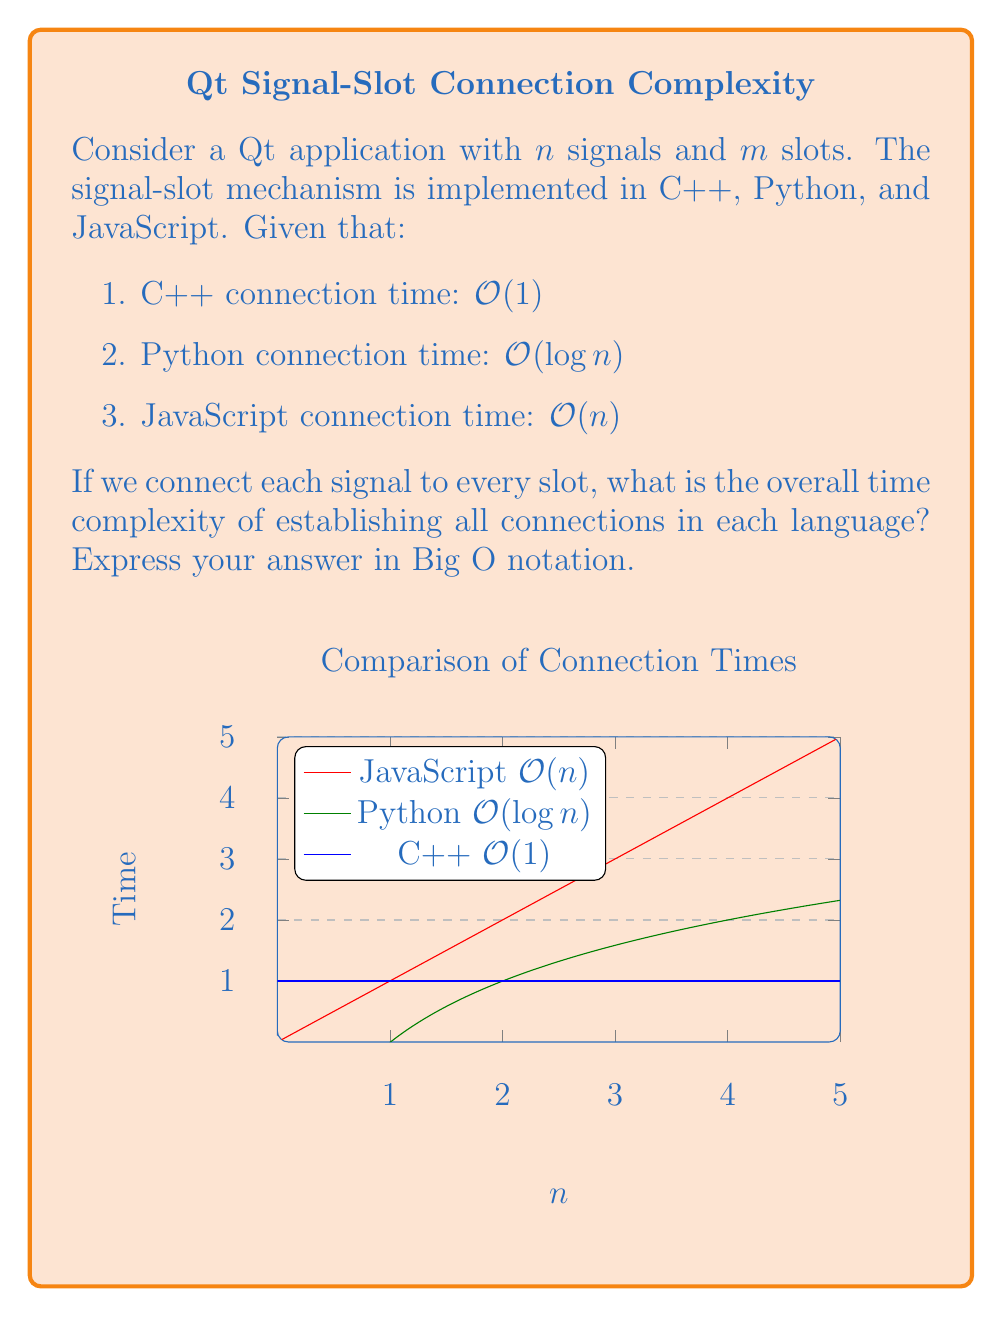Could you help me with this problem? Let's approach this step-by-step:

1) First, we need to determine how many connections we're making. With $n$ signals and $m$ slots, and each signal connecting to every slot, we have $n \times m$ connections.

2) Now, let's consider each language:

   a) C++:
      - Each connection takes $O(1)$ time.
      - We have $n \times m$ connections.
      - Total time: $O(1) \times (n \times m) = O(nm)$

   b) Python:
      - Each connection takes $O(\log n)$ time.
      - We have $n \times m$ connections.
      - Total time: $O(\log n) \times (n \times m) = O(nm \log n)$

   c) JavaScript:
      - Each connection takes $O(n)$ time.
      - We have $n \times m$ connections.
      - Total time: $O(n) \times (n \times m) = O(n^2m)$

3) To verify:
   - C++: Linear in both $n$ and $m$.
   - Python: Quasi-linear in $n$ (due to the $\log n$ factor) and linear in $m$.
   - JavaScript: Quadratic in $n$ and linear in $m$.

These complexities align with the expected performance characteristics of each language in the context of Qt's signal-slot mechanism.
Answer: C++: $O(nm)$, Python: $O(nm \log n)$, JavaScript: $O(n^2m)$ 